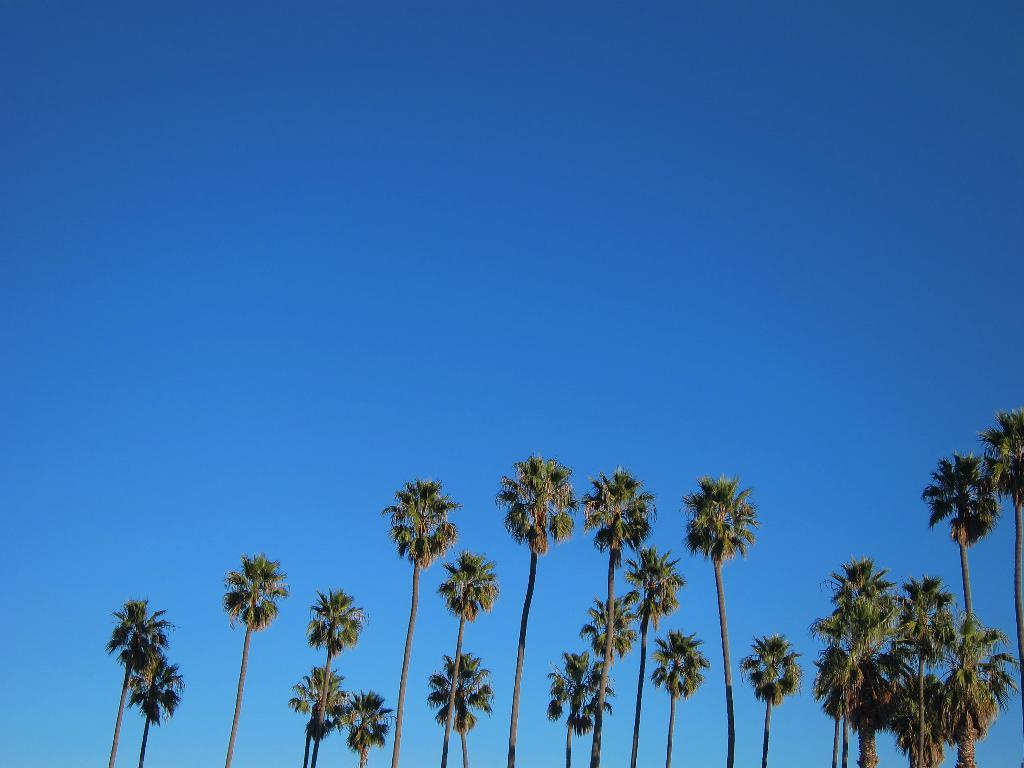What type of vegetation is present in the image? There are many trees in the image. What is the condition of the sky in the image? The sky is blue and clear in the image. Can you hear the trees smiling in the image? Trees do not have the ability to smile, and there is no sound present in the image. 